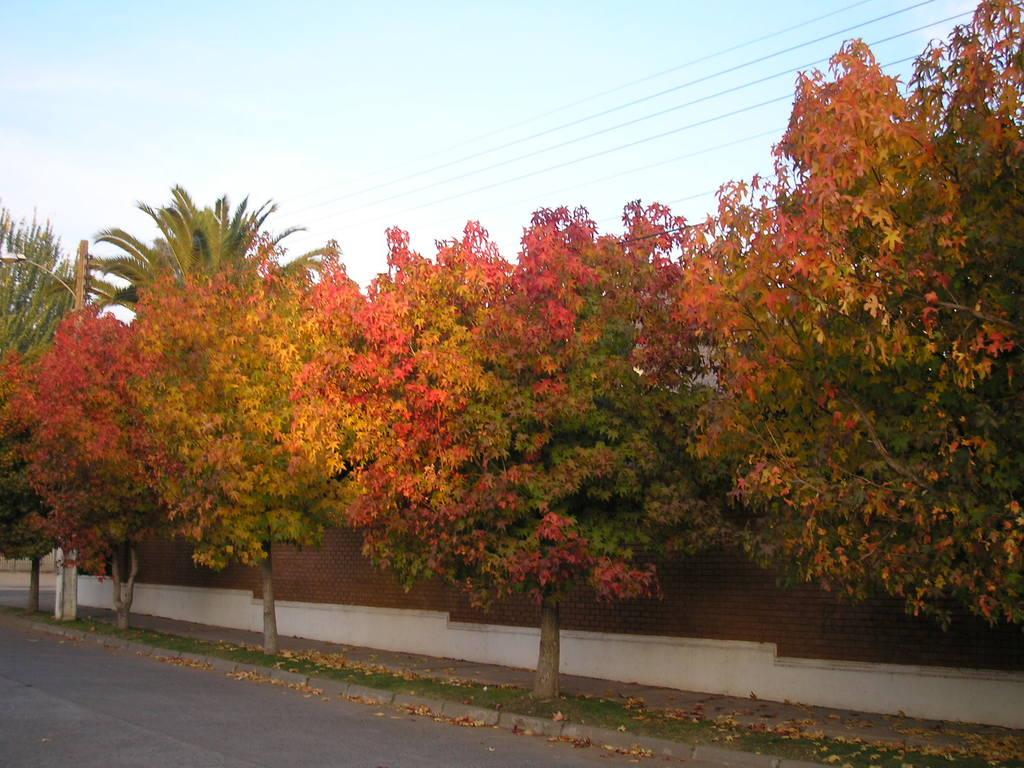What type of vegetation can be seen in the image? There are trees in the image. What structure is present in the image? There is a light pole in the image. What architectural feature is visible in the image? There is a wall in the image. What is located at the top of the image? There are wires and the sky visible at the top of the image. What is located at the bottom of the image? There is a road at the bottom of the image. Can you tell me how many donkeys are present in the image? There are no donkeys present in the image. What type of market can be seen in the image? There is no market present in the image. 